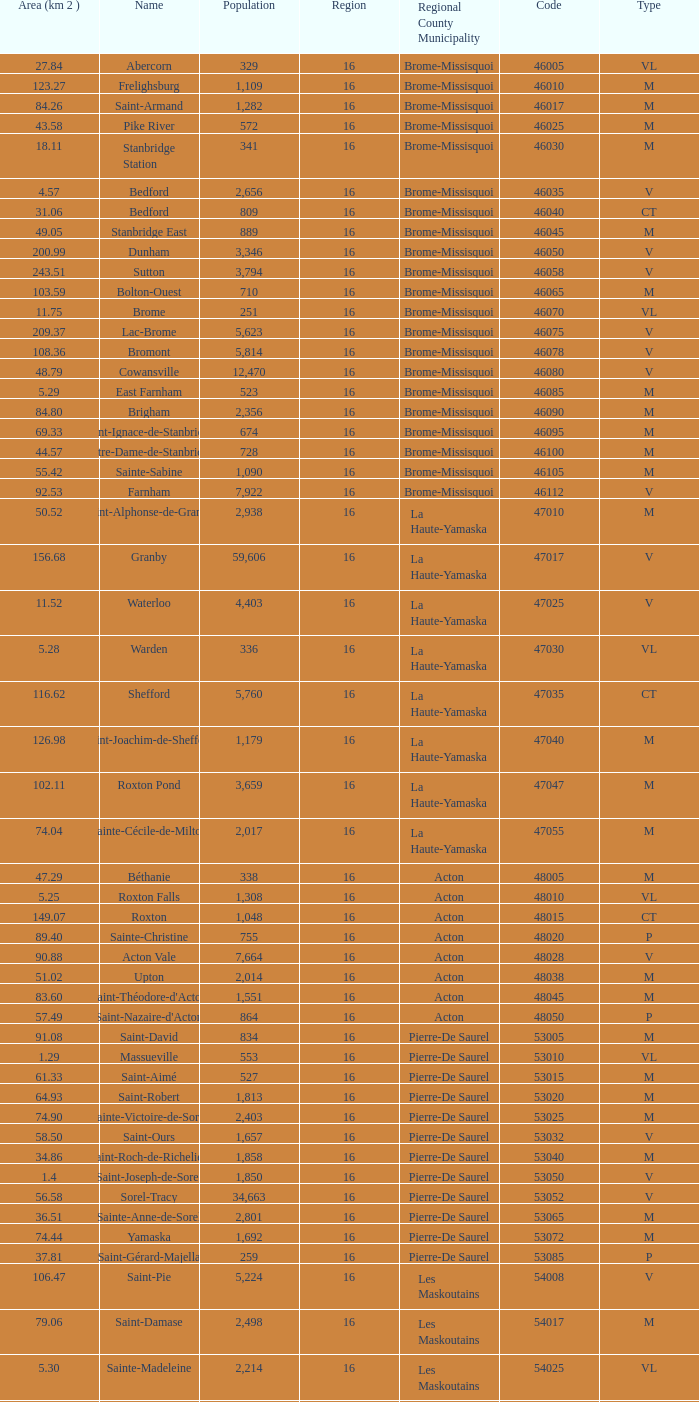What is the code for a Le Haut-Saint-Laurent municipality that has 16 or more regions? None. 